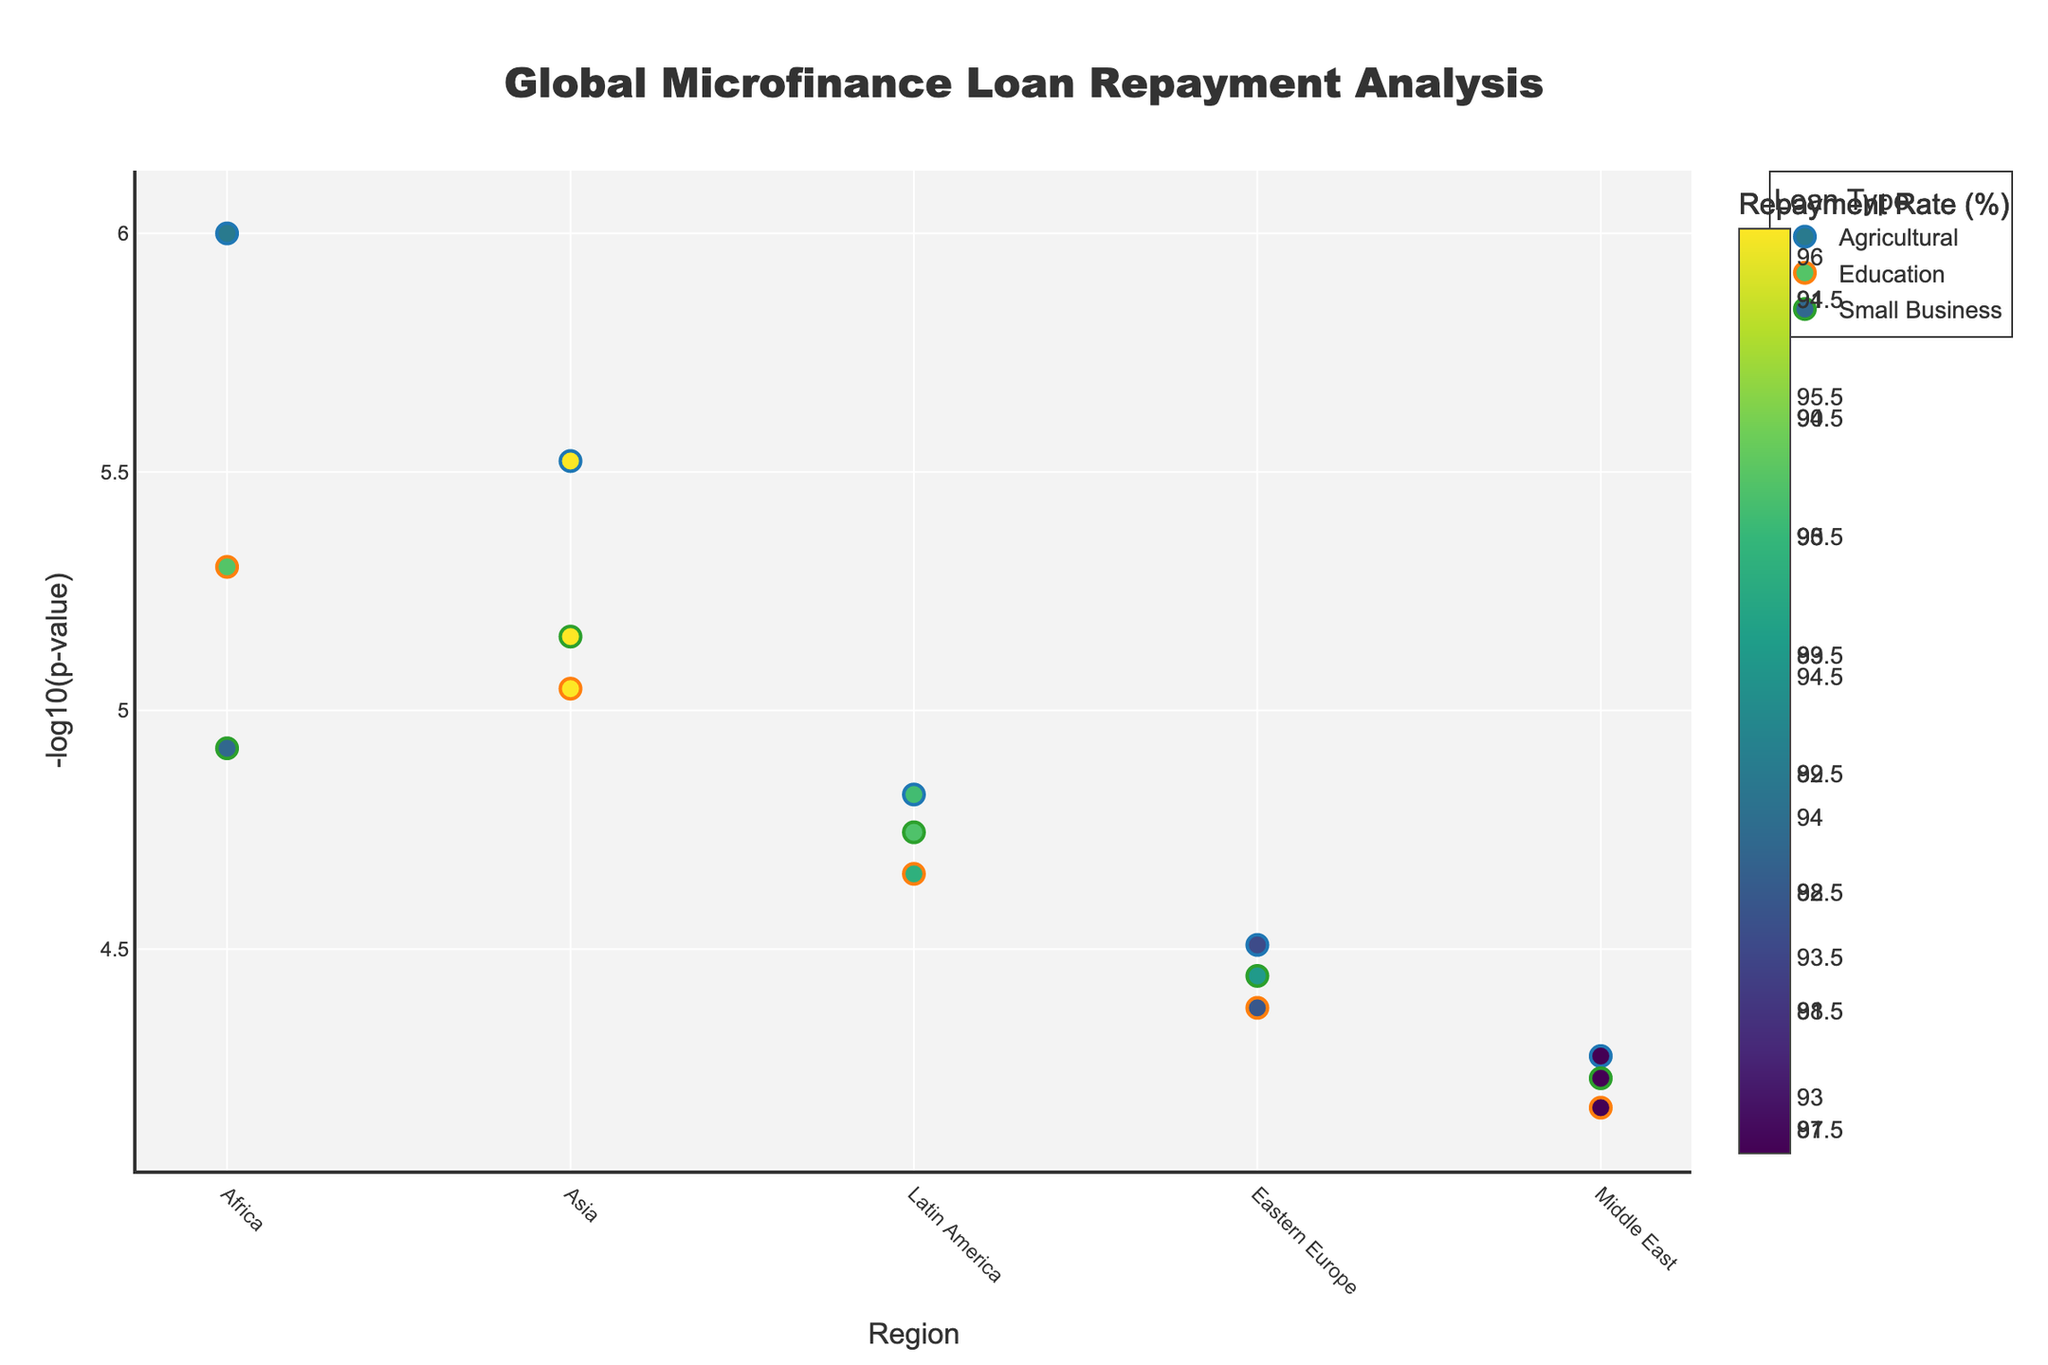What's the title of the plot? The title of the plot is displayed at the top center in a large, bold font to provide viewers with an overview of the subject matter covered.
Answer: Global Microfinance Loan Repayment Analysis How many regions are represented in the plot? The regions are indicated along the x-axis. By counting the unique labels, we can determine the number of regions being analyzed.
Answer: 5 What does the color representation on the markers indicate? The color of the markers corresponds to the repayment rate percentage, given by the color legend on the right side of the plot.
Answer: Repayment Rate (%) Which loan type has the highest -log10(p-value) in the Africa region? Locate Africa on the x-axis and identify the loan type with the highest marker on the y-axis, representing the -log10(p-value).
Answer: Agricultural Which region has the lowest repayment rate for Small Business loans? Identify the Small Business loan markers and then find the one with the lowest value in the color gradient, as indicated by the color legend.
Answer: Middle East What is the range of -log10(p-values) for Education loans across all regions? For Education loans, find the minimum and maximum -log10(p-value) among the plotted points. This is done by identifying the lowest and highest y-values for the Education loan type.
Answer: 5.17 to 6.30 How do the repayment rates for Agricultural loans in Africa and Latin America compare? Find the markers for Agricultural loans in the Africa and Latin America regions and compare their colors to see which is higher or lower, referencing the color legend for precise rates.
Answer: Africa: 92.5%, Latin America: 93.6% Is there any region where the -log10(p-value) for Education loans is greater than that for Agricultural loans? For each region, compare the -log10(p-values) of the Education and Agricultural loans. If the marker for Education is higher on the y-axis than the Agricultural marker, that region qualifies.
Answer: Asia What trend do you observe in the -log10(p-values) for Small Business loans across different regions? Scan through the Small Business markers from left to right (i.e., across regions) and observe if there's an overall increase, decrease, or no specific pattern in the heights (y-values).
Answer: The values decrease from Africa to the Middle East 